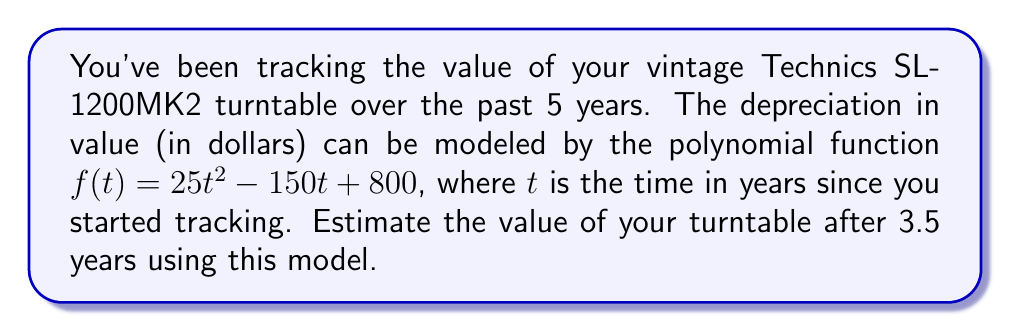Solve this math problem. To solve this problem, we need to follow these steps:

1) We're given the polynomial function: $f(t) = 25t^2 - 150t + 800$

2) We need to find $f(3.5)$, as we want to know the value after 3.5 years.

3) Let's substitute $t = 3.5$ into the function:

   $f(3.5) = 25(3.5)^2 - 150(3.5) + 800$

4) First, let's calculate $(3.5)^2$:
   $(3.5)^2 = 12.25$

5) Now, let's substitute this back and calculate each term:

   $25(12.25) = 306.25$
   $-150(3.5) = -525$
   $800$ remains as is

6) Adding these terms:

   $306.25 - 525 + 800 = 581.25$

Therefore, the estimated value of the turntable after 3.5 years is $581.25.
Answer: $581.25 